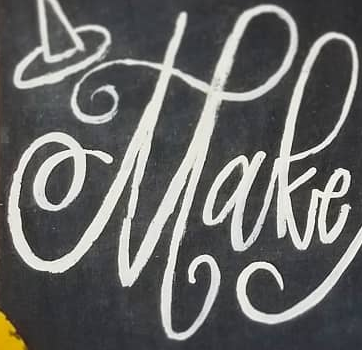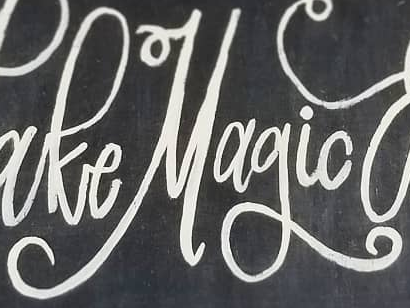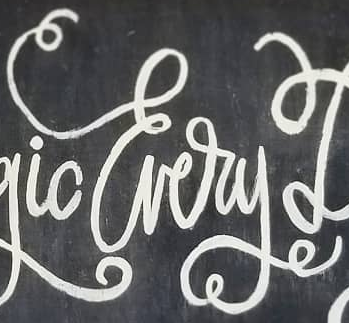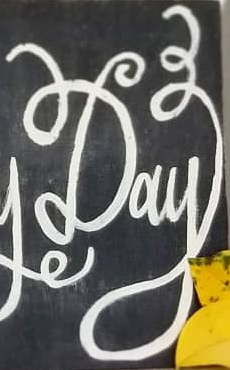Transcribe the words shown in these images in order, separated by a semicolon. Make; Magic; Every; Day 